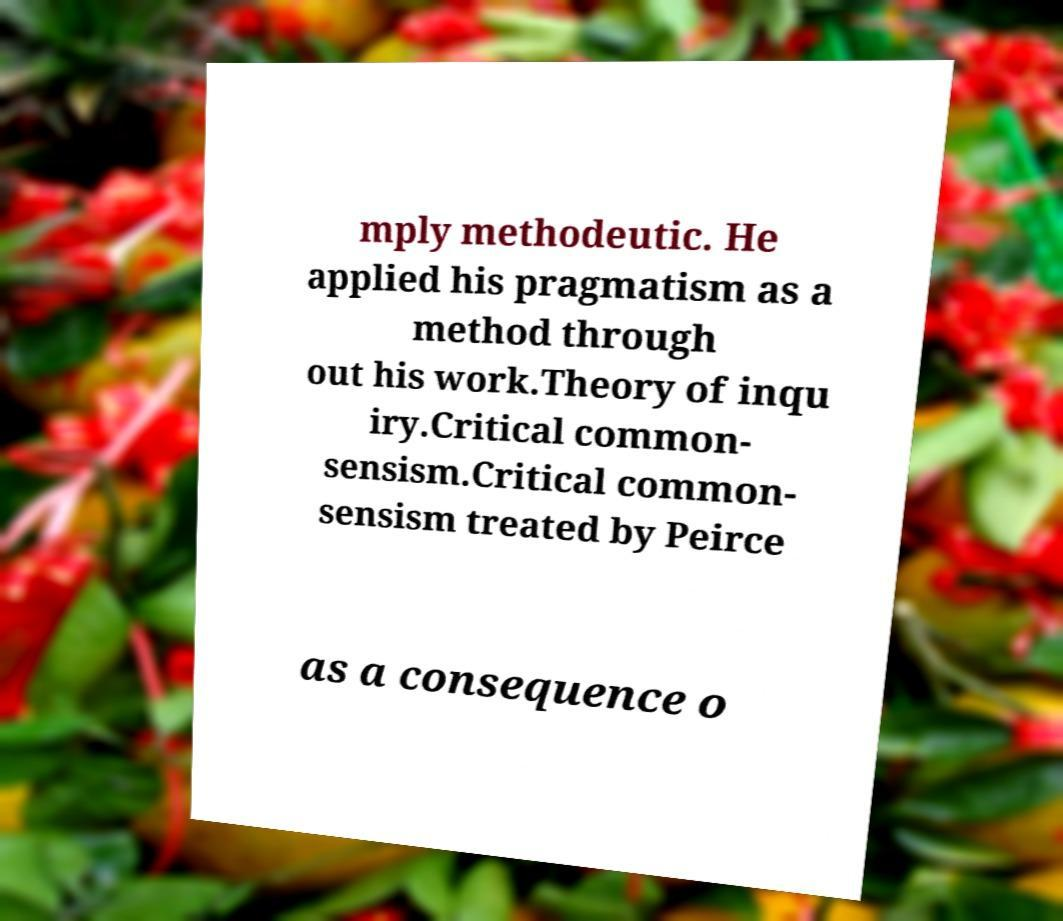I need the written content from this picture converted into text. Can you do that? mply methodeutic. He applied his pragmatism as a method through out his work.Theory of inqu iry.Critical common- sensism.Critical common- sensism treated by Peirce as a consequence o 